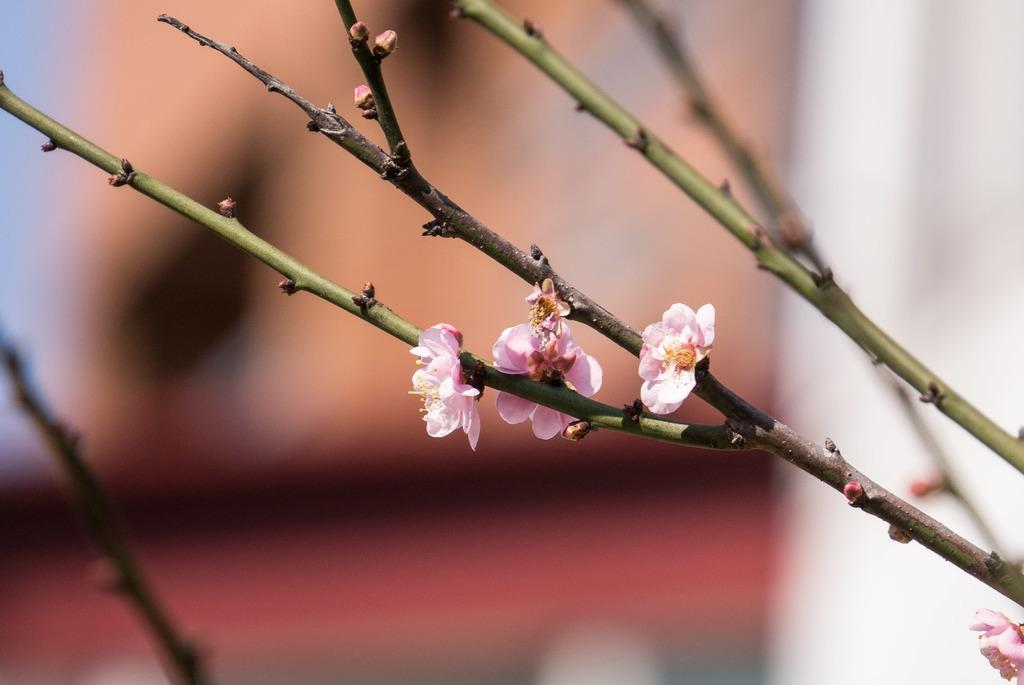What type of living organism can be seen in the image? There is a plant in the image. What specific feature of the plant is visible? The plant has flowers. What advice does the mom give about the sugar in the image? There is no mom or sugar present in the image, as it only features a plant with flowers. 